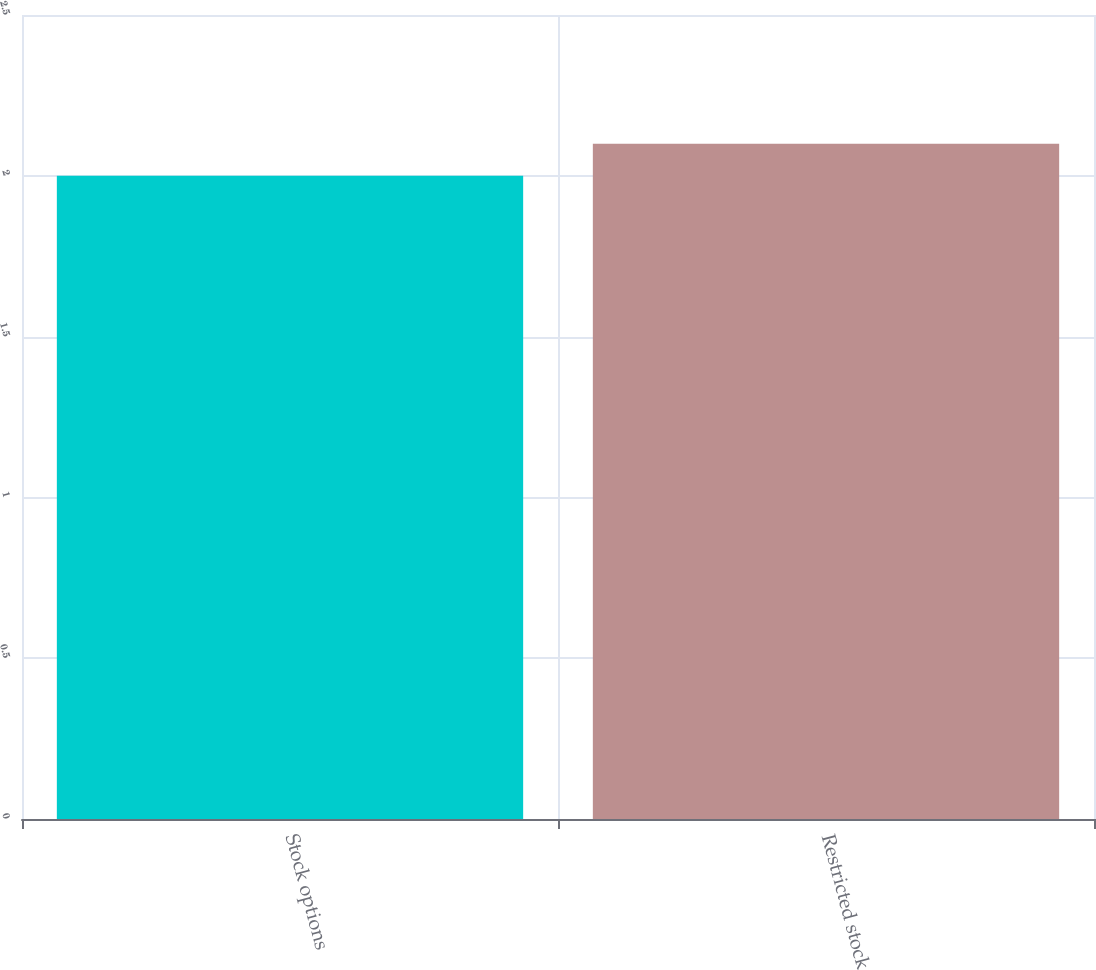Convert chart to OTSL. <chart><loc_0><loc_0><loc_500><loc_500><bar_chart><fcel>Stock options<fcel>Restricted stock<nl><fcel>2<fcel>2.1<nl></chart> 